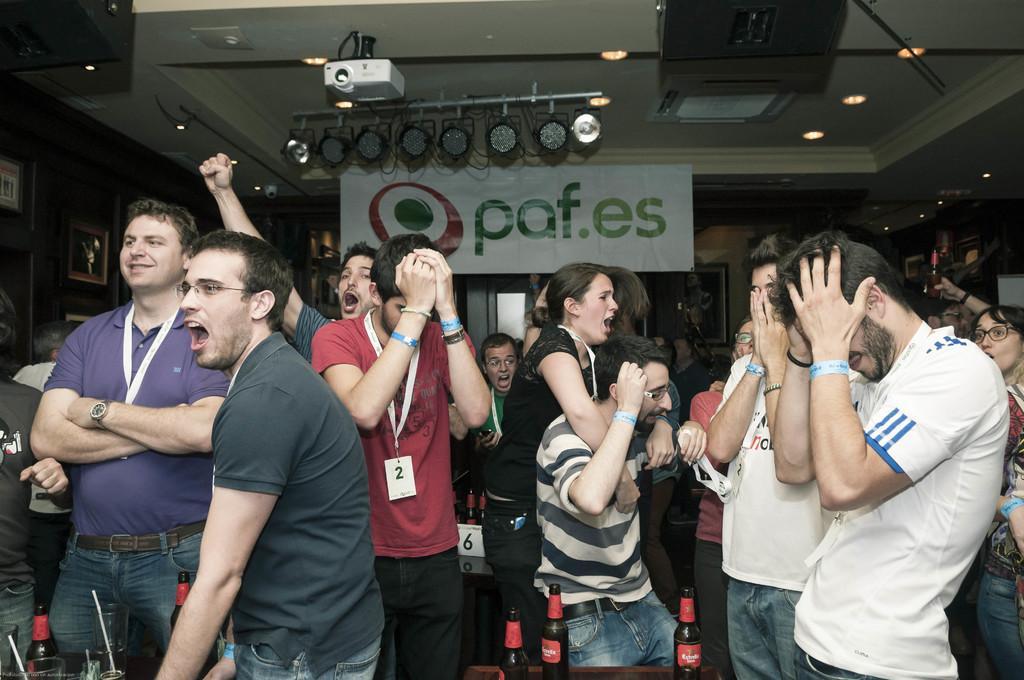Describe this image in one or two sentences. This is the picture of a room. In this image there are group of people standing and shouting. There are bottles and glasses on the table. At the top there is a banner and there are speakers and lights and there is a projector. There are frames on the wall. 